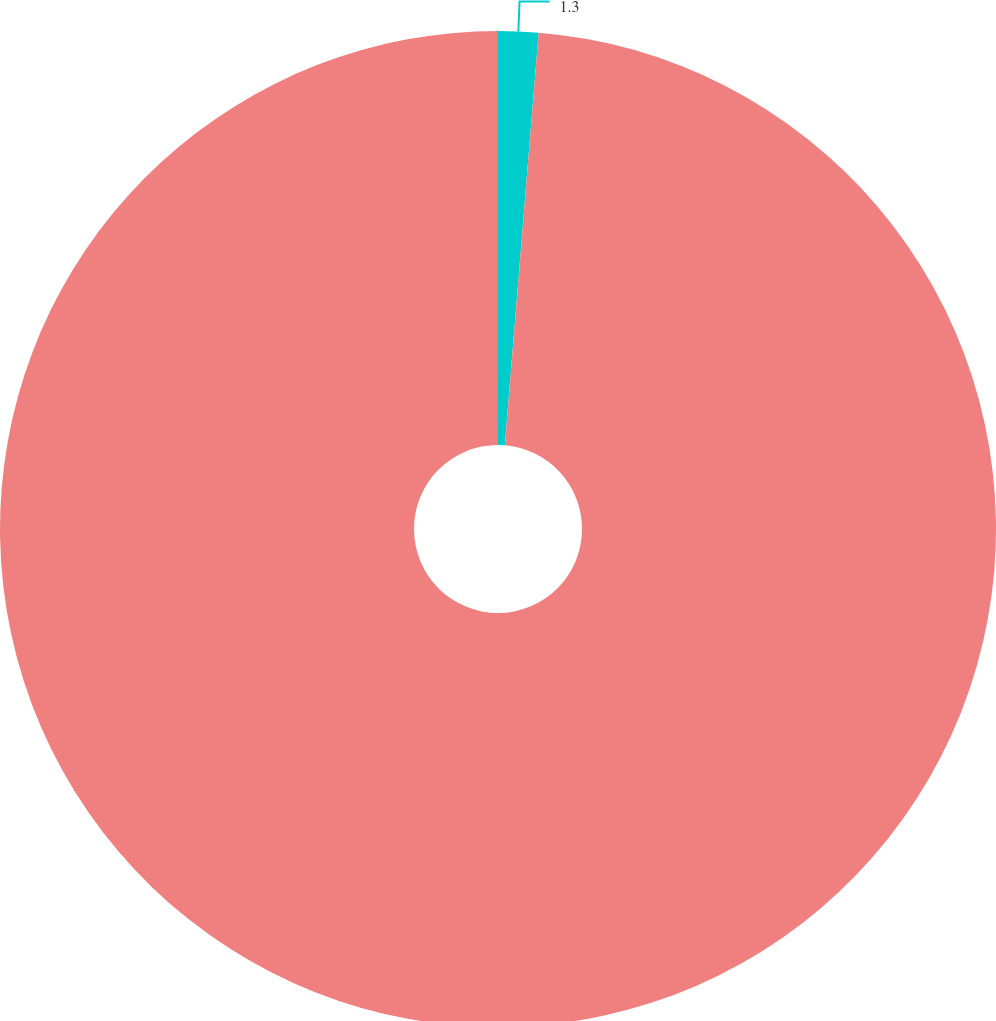<chart> <loc_0><loc_0><loc_500><loc_500><pie_chart><ecel><fcel>Numberofnewclaimsduringtheyear<nl><fcel>1.3%<fcel>98.7%<nl></chart> 